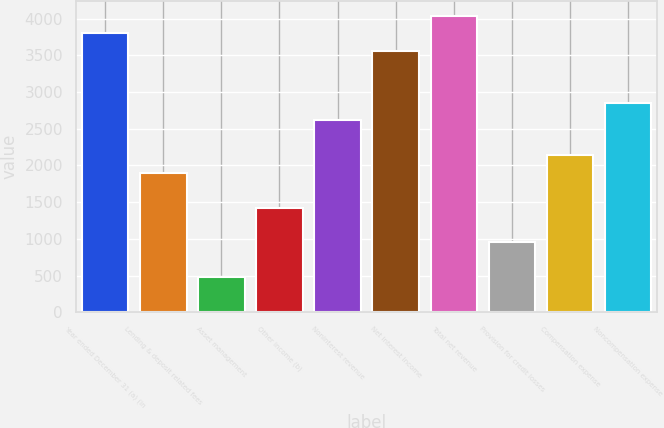Convert chart. <chart><loc_0><loc_0><loc_500><loc_500><bar_chart><fcel>Year ended December 31 (a) (in<fcel>Lending & deposit related fees<fcel>Asset management<fcel>Other income (b)<fcel>Noninterest revenue<fcel>Net interest income<fcel>Total net revenue<fcel>Provision for credit losses<fcel>Compensation expense<fcel>Noncompensation expense<nl><fcel>3797.35<fcel>1899.51<fcel>476.13<fcel>1425.05<fcel>2611.2<fcel>3560.12<fcel>4034.58<fcel>950.59<fcel>2136.74<fcel>2848.43<nl></chart> 